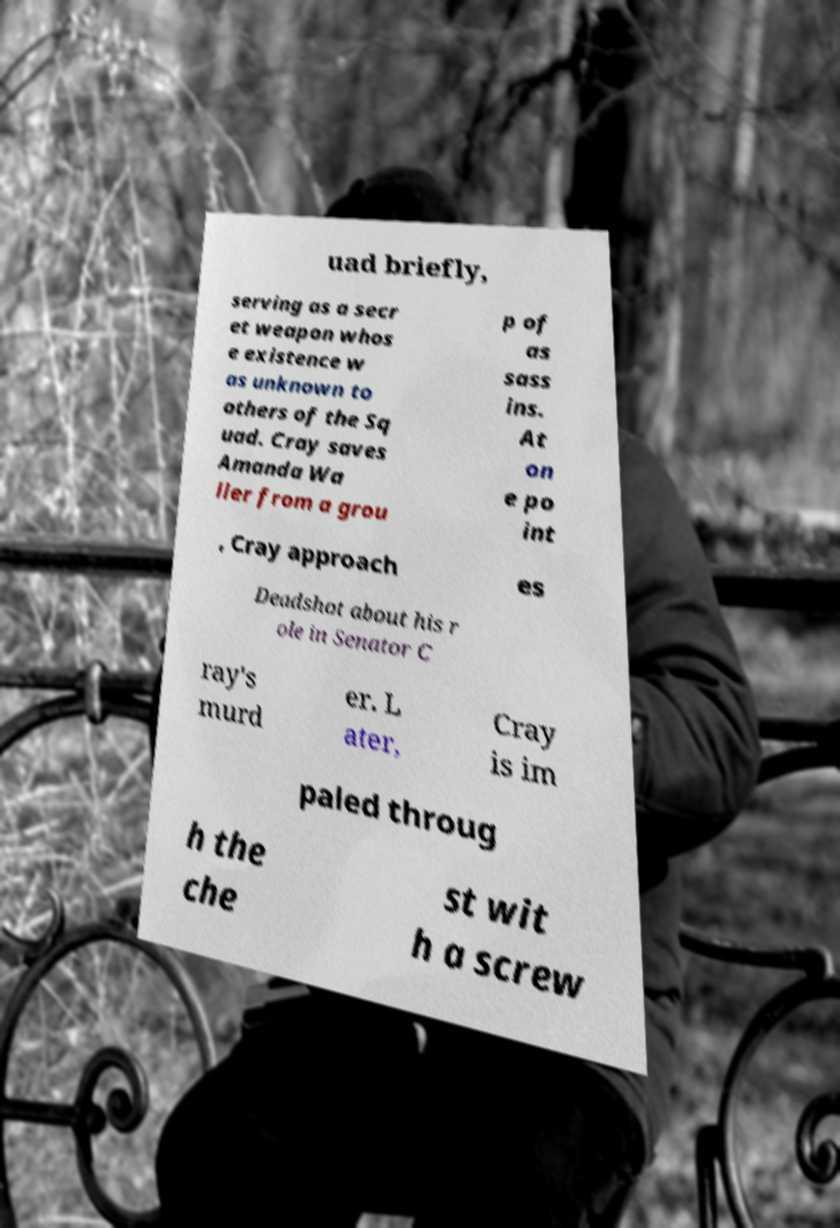There's text embedded in this image that I need extracted. Can you transcribe it verbatim? uad briefly, serving as a secr et weapon whos e existence w as unknown to others of the Sq uad. Cray saves Amanda Wa ller from a grou p of as sass ins. At on e po int , Cray approach es Deadshot about his r ole in Senator C ray's murd er. L ater, Cray is im paled throug h the che st wit h a screw 